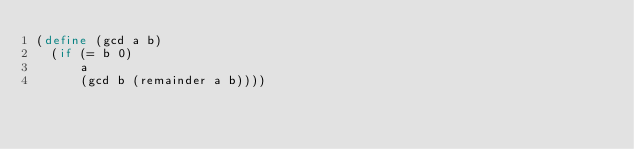Convert code to text. <code><loc_0><loc_0><loc_500><loc_500><_Scheme_>(define (gcd a b)
  (if (= b 0)
      a
      (gcd b (remainder a b))))</code> 